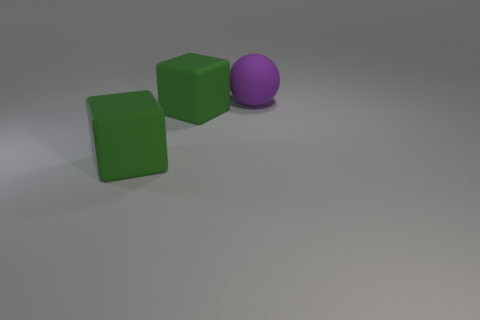Add 2 big matte things. How many objects exist? 5 Subtract all cubes. How many objects are left? 1 Subtract 0 purple blocks. How many objects are left? 3 Subtract all large green rubber blocks. Subtract all rubber spheres. How many objects are left? 0 Add 2 purple matte objects. How many purple matte objects are left? 3 Add 1 large balls. How many large balls exist? 2 